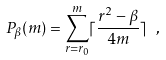Convert formula to latex. <formula><loc_0><loc_0><loc_500><loc_500>P _ { \beta } ( m ) = \sum _ { r = r _ { 0 } } ^ { m } \lceil \frac { r ^ { 2 } - \beta } { 4 m } \rceil \ ,</formula> 